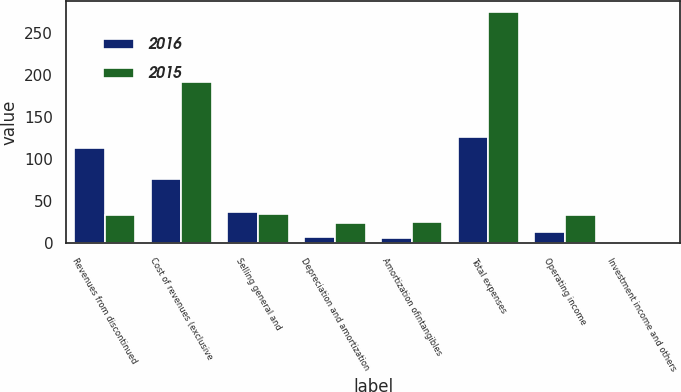Convert chart. <chart><loc_0><loc_0><loc_500><loc_500><stacked_bar_chart><ecel><fcel>Revenues from discontinued<fcel>Cost of revenues (exclusive<fcel>Selling general and<fcel>Depreciation and amortization<fcel>Amortization ofintangibles<fcel>Total expenses<fcel>Operating income<fcel>Investment income and others<nl><fcel>2016<fcel>112.3<fcel>75.9<fcel>36.5<fcel>7.1<fcel>5.9<fcel>125.4<fcel>13.1<fcel>0.2<nl><fcel>2015<fcel>33.3<fcel>191.3<fcel>34.3<fcel>24<fcel>24.4<fcel>274<fcel>33.3<fcel>0.1<nl></chart> 